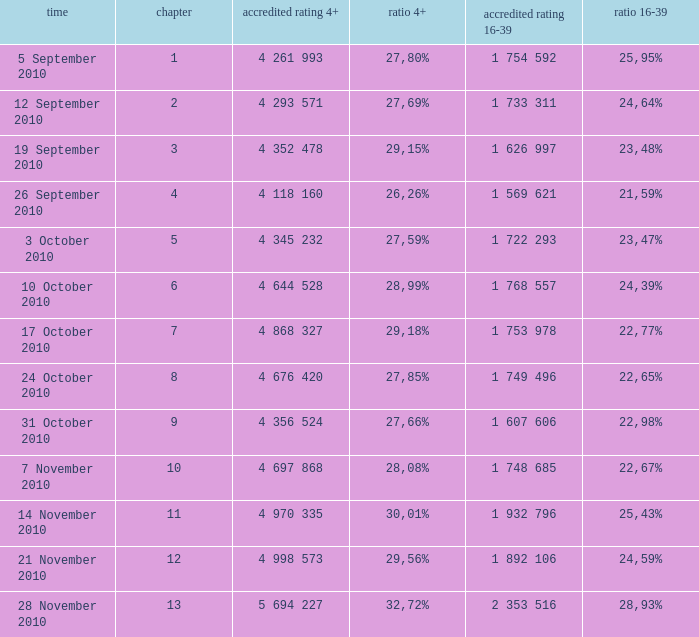What is the official 4+ rating of the episode with a 16-39 share of 24,59%? 4 998 573. 